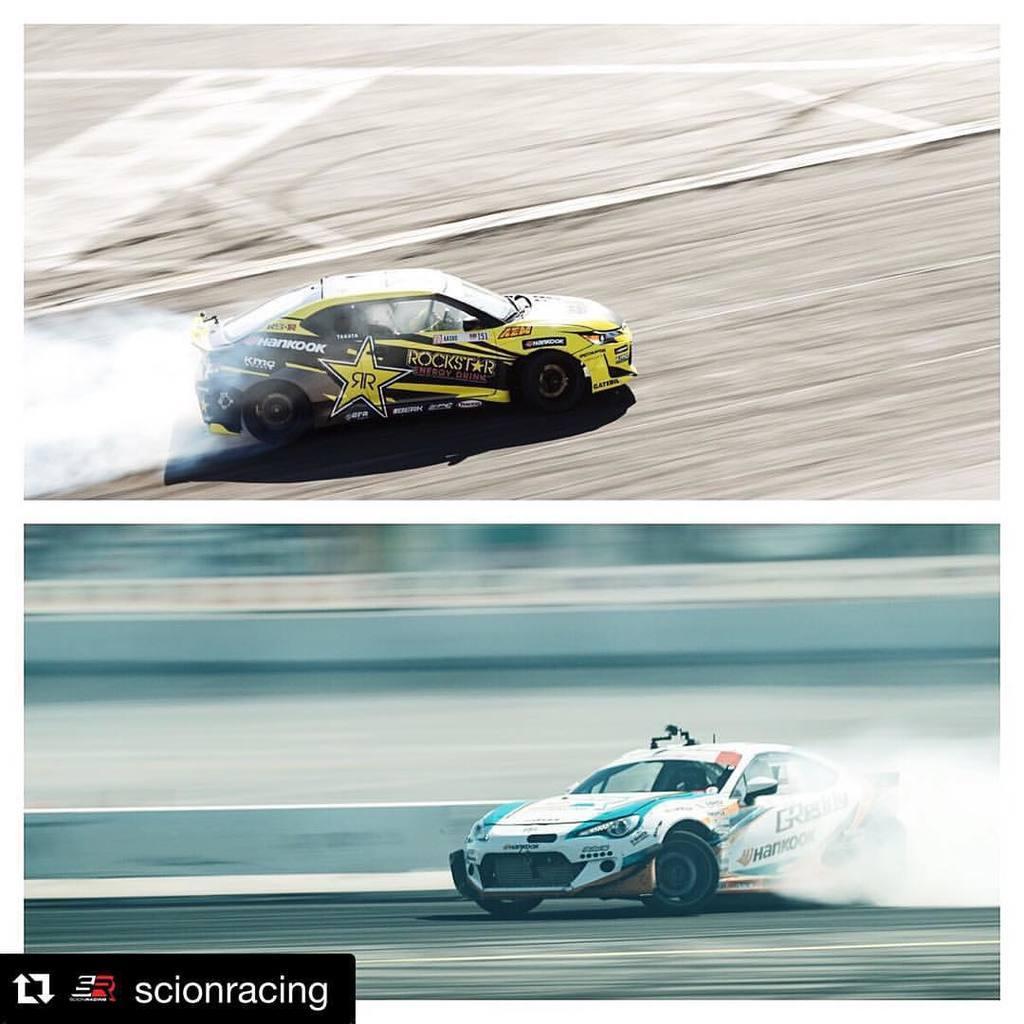Please provide a concise description of this image. In this image there are racing cars moving on the road and at the bottom left of the image there is some text written on it. 